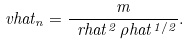<formula> <loc_0><loc_0><loc_500><loc_500>\ v h a t _ { n } = \frac { m } { \ r h a t ^ { 2 } \, \rho h a t ^ { 1 / 2 } } .</formula> 